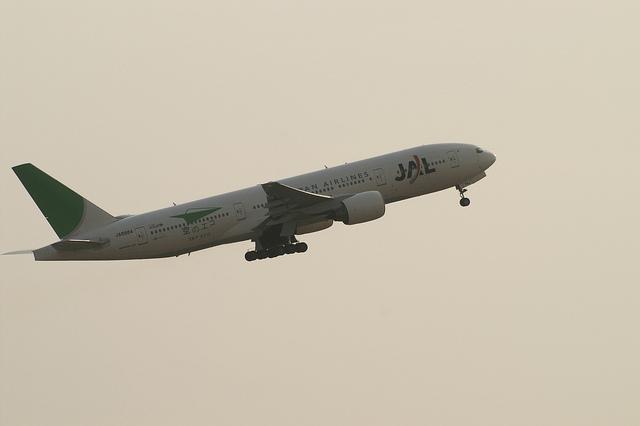Is the plane landing?
Concise answer only. No. Is the plane powered by propellers?
Be succinct. No. What is the name of the airline?
Answer briefly. Jal. What website would you visit to learn more about this flight?
Give a very brief answer. Jal. What airline is this?
Quick response, please. Jal. What color is the sky?
Give a very brief answer. White. Is this plane landing?
Concise answer only. No. 